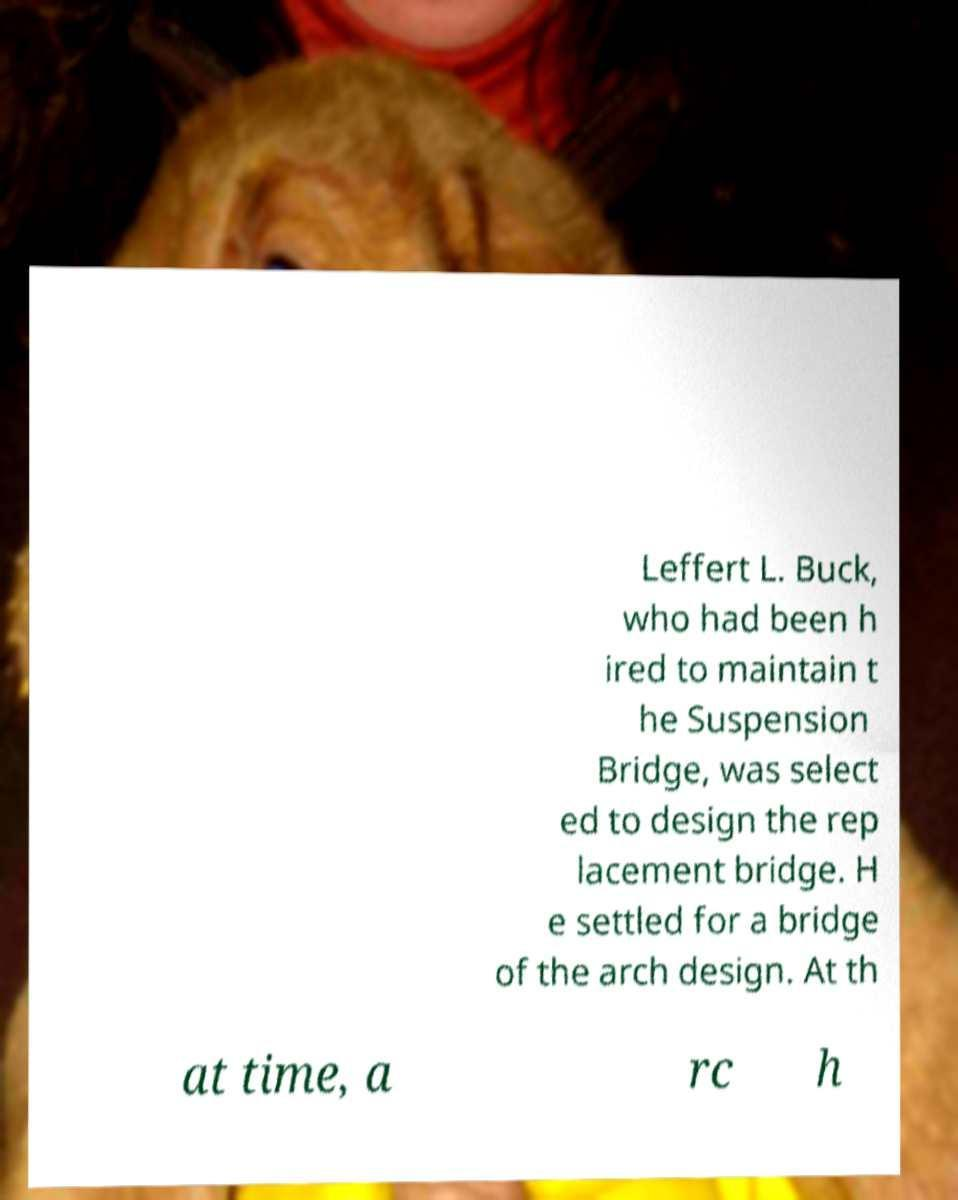Please read and relay the text visible in this image. What does it say? Leffert L. Buck, who had been h ired to maintain t he Suspension Bridge, was select ed to design the rep lacement bridge. H e settled for a bridge of the arch design. At th at time, a rc h 